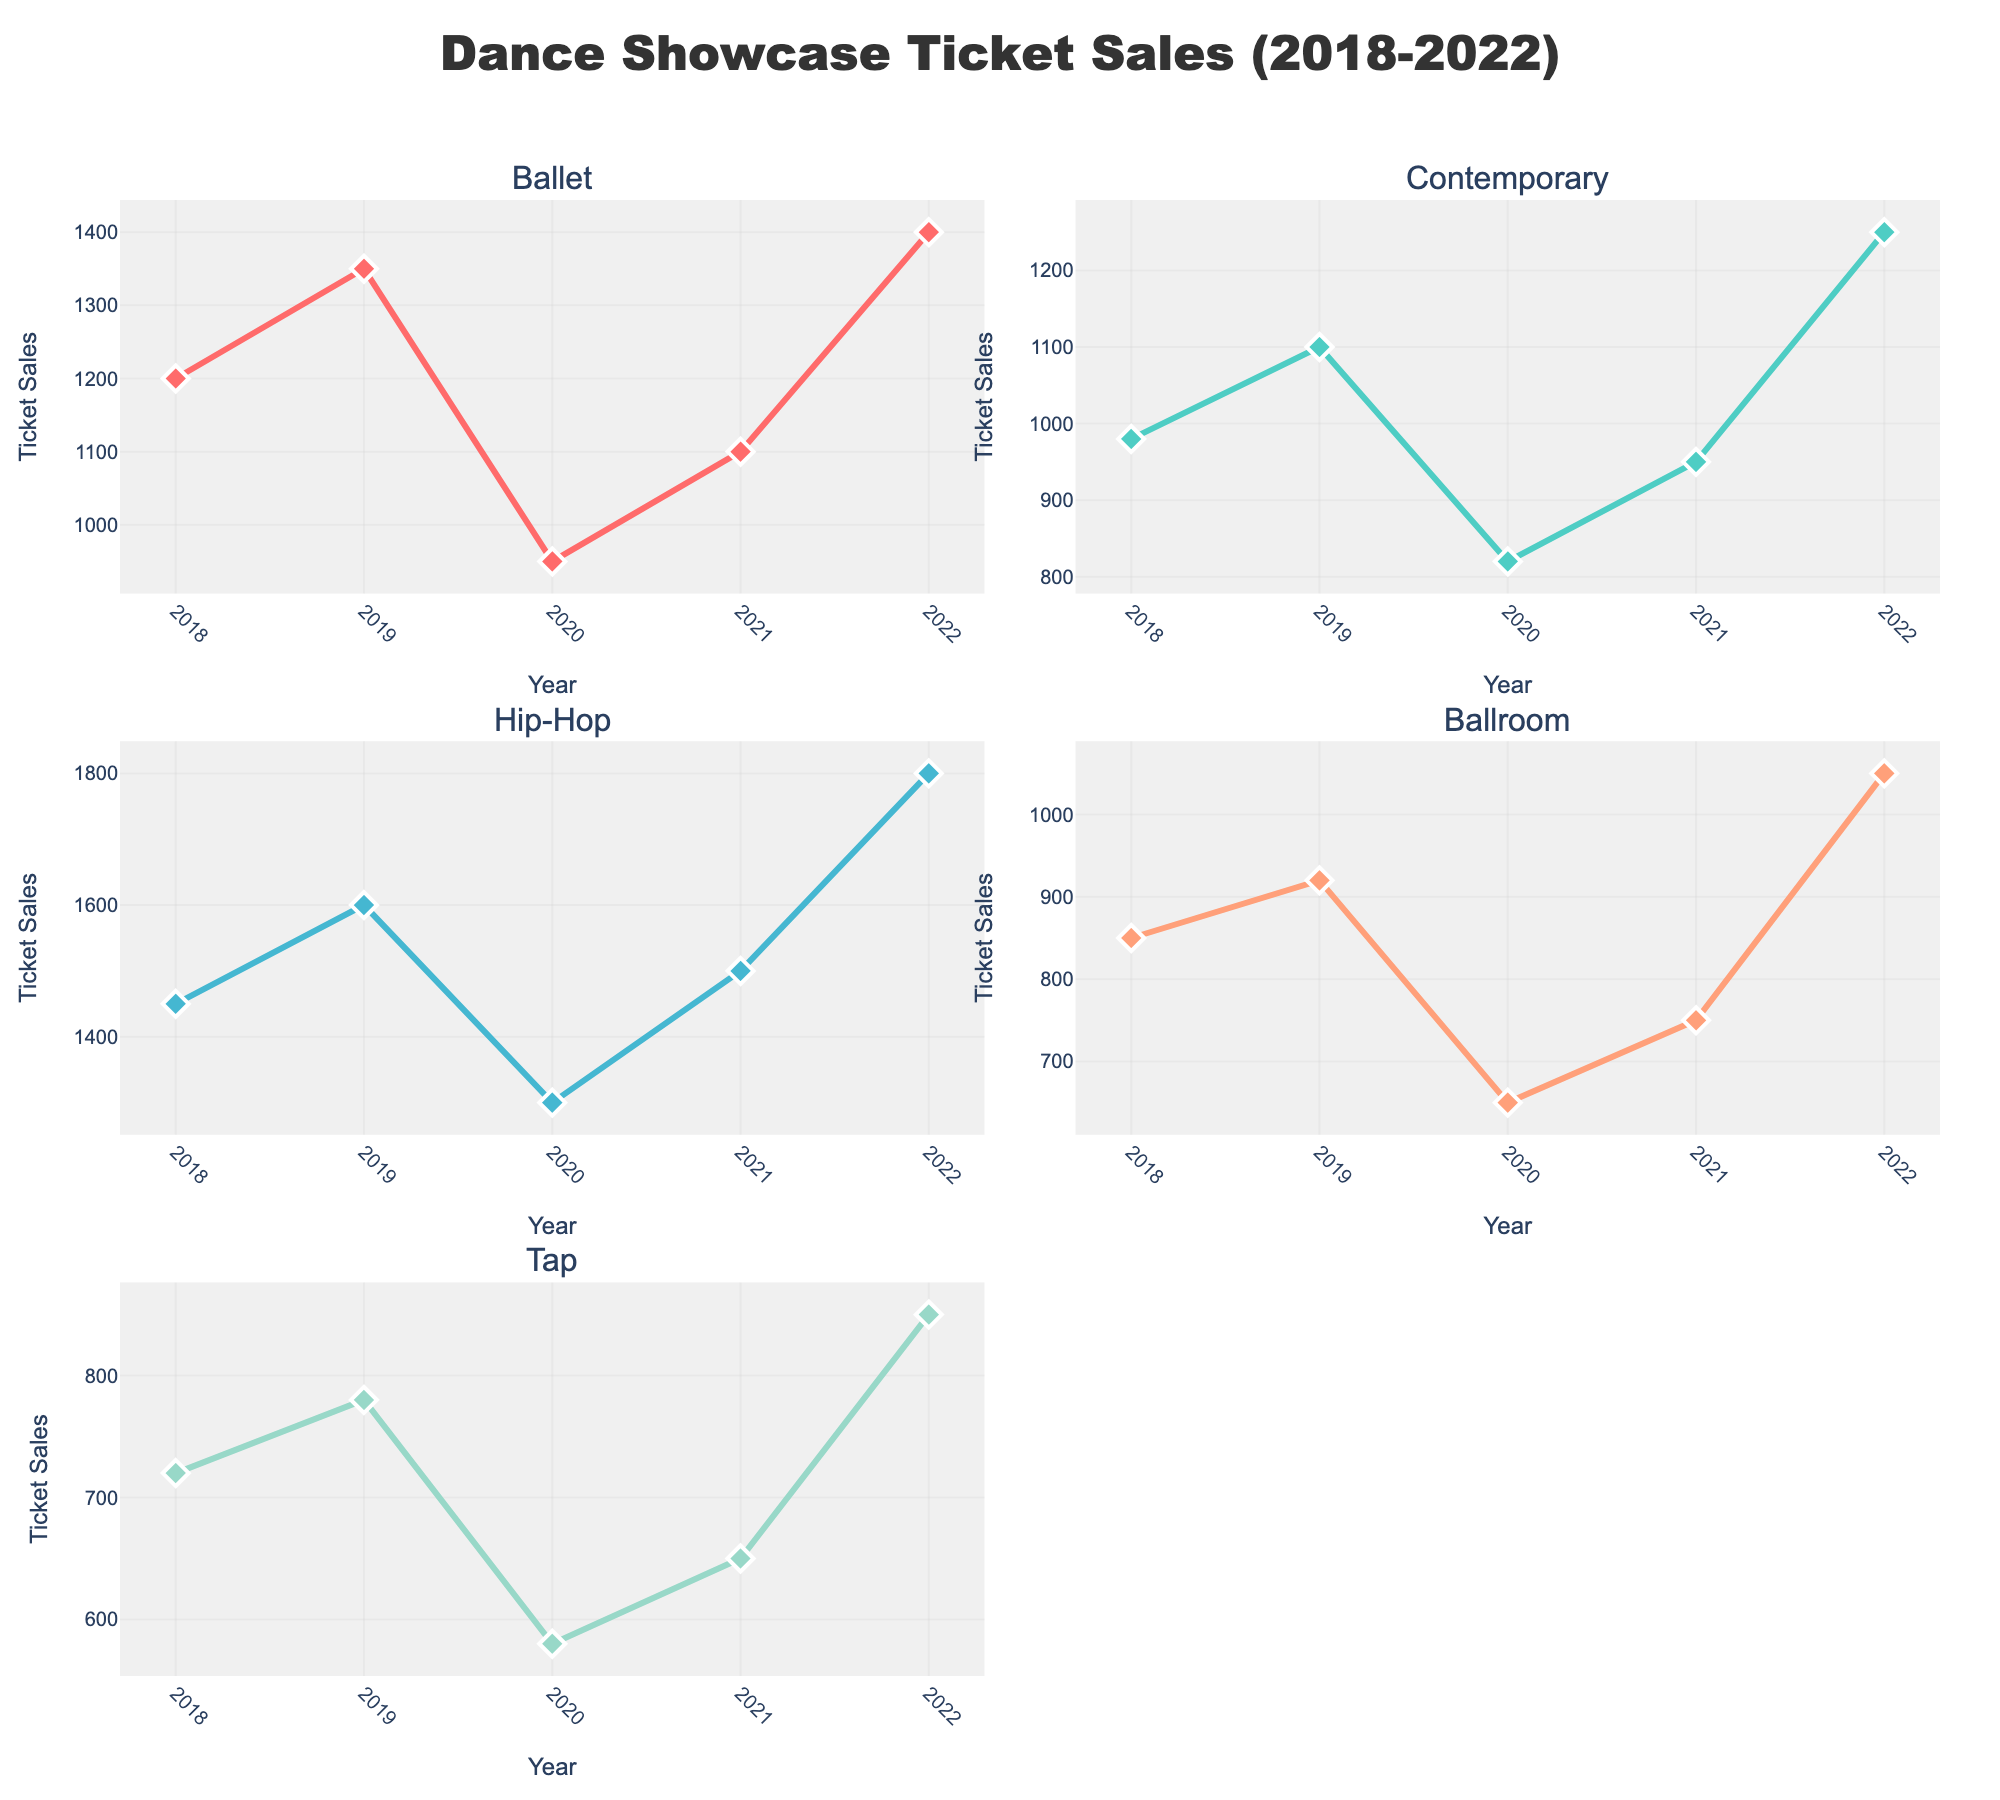What is the title of the figure? The title is located at the top center of the figure.
Answer: Dance Showcase Ticket Sales (2018-2022) How many data points are there for each dance category? Each category spans from 2018 to 2022, which means there are five data points for each category.
Answer: 5 Which dance category had the highest ticket sales in 2019? The 2019 data points for each category show that Hip-Hop had the highest ticket sales with 1,600 tickets.
Answer: Hip-Hop What trend do you observe in the Ballroom category from 2018 to 2022? From 2018 to 2022, the Ballroom category shows a fluctuating trend with an initial increase in 2019, a drop in 2020, a slight increase in 2021, and then a notable rise in 2022.
Answer: Fluctuating By how much did Ballet ticket sales increase from 2021 to 2022? Ballet ticket sales in 2021 were 1,100, and in 2022 they were 1,400. The increase is 1,400 - 1,100 = 300 tickets.
Answer: 300 Which category had the most significant drop in ticket sales between any two consecutive years? Between 2019 and 2020, Ballet had a drop from 1,350 to 950 tickets, which is a decline of 400 tickets—the most significant drop across all categories and years.
Answer: Ballet What is the overall trend for Contemporary dance ticket sales over the 5 years? Contemporary dance shows a generally increasing trend with a dip in 2020 but recovering afterward.
Answer: Increasing Across all categories, which year had the lowest ticket sales for Tap dance? The Tap dance category had the lowest ticket sales in 2020 with 580 tickets.
Answer: 2020 Did any dance category have consistent increases in ticket sales every year? No category had consistent increases every year; all categories experienced at least one year with a drop in ticket sales.
Answer: No 